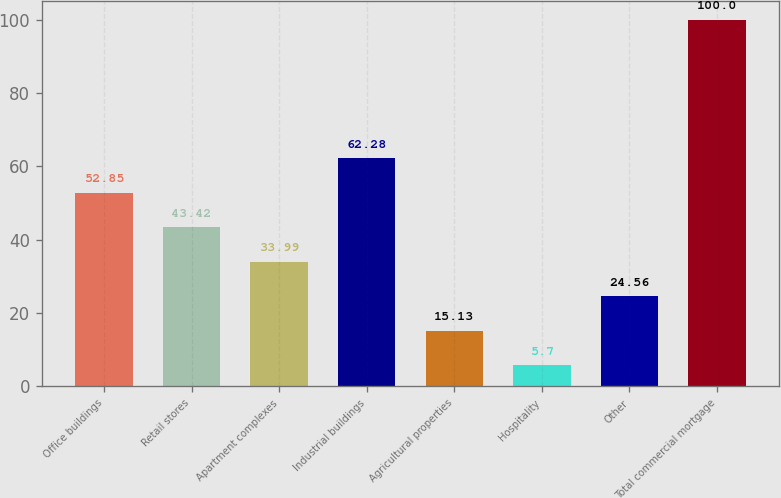Convert chart to OTSL. <chart><loc_0><loc_0><loc_500><loc_500><bar_chart><fcel>Office buildings<fcel>Retail stores<fcel>Apartment complexes<fcel>Industrial buildings<fcel>Agricultural properties<fcel>Hospitality<fcel>Other<fcel>Total commercial mortgage<nl><fcel>52.85<fcel>43.42<fcel>33.99<fcel>62.28<fcel>15.13<fcel>5.7<fcel>24.56<fcel>100<nl></chart> 